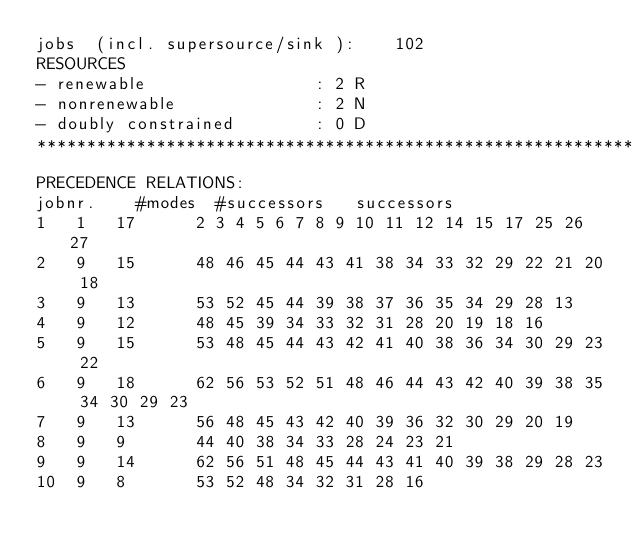Convert code to text. <code><loc_0><loc_0><loc_500><loc_500><_ObjectiveC_>jobs  (incl. supersource/sink ):	102
RESOURCES
- renewable                 : 2 R
- nonrenewable              : 2 N
- doubly constrained        : 0 D
************************************************************************
PRECEDENCE RELATIONS:
jobnr.    #modes  #successors   successors
1	1	17		2 3 4 5 6 7 8 9 10 11 12 14 15 17 25 26 27 
2	9	15		48 46 45 44 43 41 38 34 33 32 29 22 21 20 18 
3	9	13		53 52 45 44 39 38 37 36 35 34 29 28 13 
4	9	12		48 45 39 34 33 32 31 28 20 19 18 16 
5	9	15		53 48 45 44 43 42 41 40 38 36 34 30 29 23 22 
6	9	18		62 56 53 52 51 48 46 44 43 42 40 39 38 35 34 30 29 23 
7	9	13		56 48 45 43 42 40 39 36 32 30 29 20 19 
8	9	9		44 40 38 34 33 28 24 23 21 
9	9	14		62 56 51 48 45 44 43 41 40 39 38 29 28 23 
10	9	8		53 52 48 34 32 31 28 16 </code> 